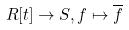Convert formula to latex. <formula><loc_0><loc_0><loc_500><loc_500>R [ t ] \rightarrow S , f \mapsto \overline { f }</formula> 